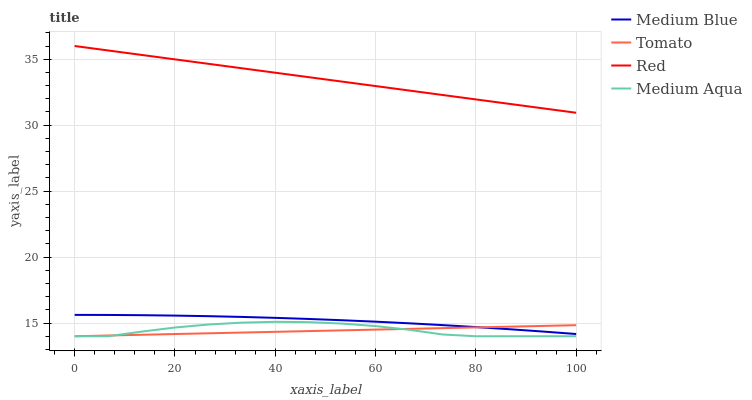Does Tomato have the minimum area under the curve?
Answer yes or no. Yes. Does Red have the maximum area under the curve?
Answer yes or no. Yes. Does Medium Aqua have the minimum area under the curve?
Answer yes or no. No. Does Medium Aqua have the maximum area under the curve?
Answer yes or no. No. Is Red the smoothest?
Answer yes or no. Yes. Is Medium Aqua the roughest?
Answer yes or no. Yes. Is Medium Blue the smoothest?
Answer yes or no. No. Is Medium Blue the roughest?
Answer yes or no. No. Does Tomato have the lowest value?
Answer yes or no. Yes. Does Medium Blue have the lowest value?
Answer yes or no. No. Does Red have the highest value?
Answer yes or no. Yes. Does Medium Aqua have the highest value?
Answer yes or no. No. Is Tomato less than Red?
Answer yes or no. Yes. Is Red greater than Tomato?
Answer yes or no. Yes. Does Tomato intersect Medium Blue?
Answer yes or no. Yes. Is Tomato less than Medium Blue?
Answer yes or no. No. Is Tomato greater than Medium Blue?
Answer yes or no. No. Does Tomato intersect Red?
Answer yes or no. No. 